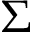<formula> <loc_0><loc_0><loc_500><loc_500>\Sigma</formula> 